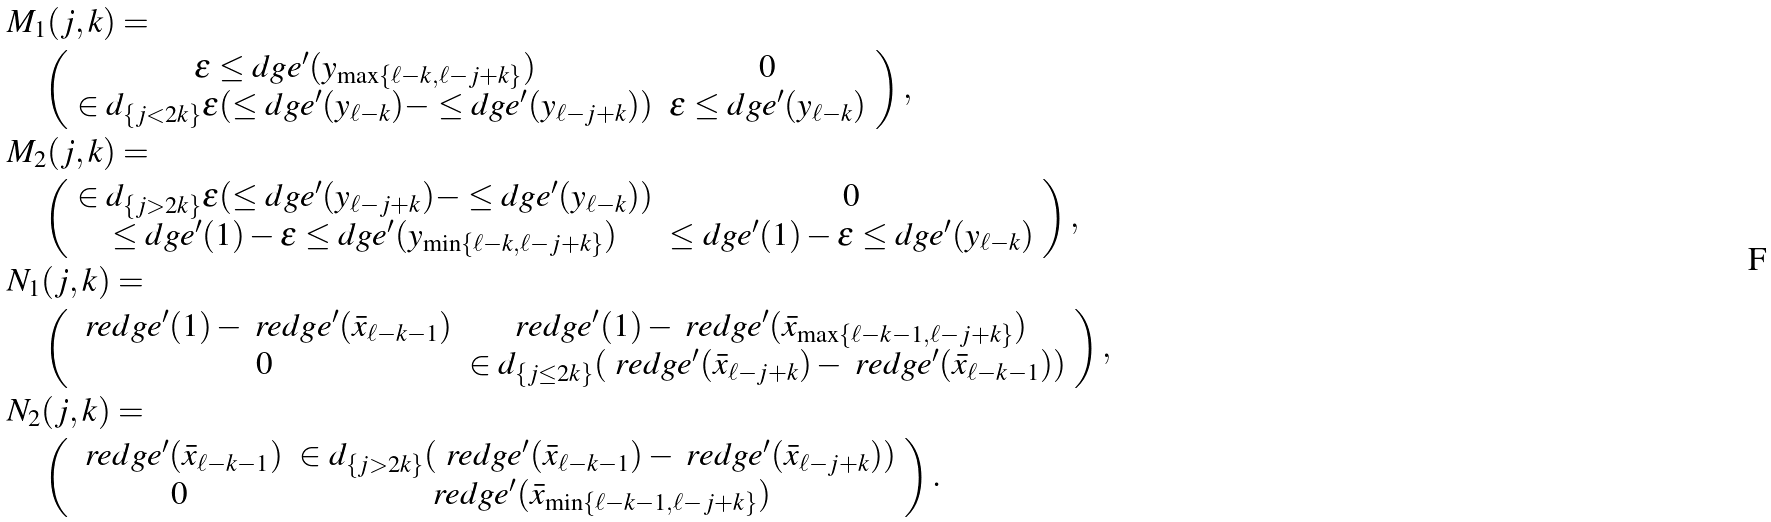Convert formula to latex. <formula><loc_0><loc_0><loc_500><loc_500>& M _ { 1 } ( j , k ) = \\ & \quad \left ( \begin{array} { c c } \epsilon \leq d g e ^ { \prime } ( y _ { \max \{ \ell - k , \ell - j + k \} } ) & 0 \\ \in d _ { \{ j < 2 k \} } \epsilon ( \leq d g e ^ { \prime } ( y _ { \ell - k } ) - \leq d g e ^ { \prime } ( y _ { \ell - j + k } ) ) & \epsilon \leq d g e ^ { \prime } ( y _ { \ell - k } ) \end{array} \right ) , \\ & M _ { 2 } ( j , k ) = \\ & \quad \left ( \begin{array} { c c } \in d _ { \{ j > 2 k \} } \epsilon ( \leq d g e ^ { \prime } ( y _ { \ell - j + k } ) - \leq d g e ^ { \prime } ( y _ { \ell - k } ) ) & 0 \\ \leq d g e ^ { \prime } ( 1 ) - \epsilon \leq d g e ^ { \prime } ( y _ { \min \{ \ell - k , \ell - j + k \} } ) & \leq d g e ^ { \prime } ( 1 ) - \epsilon \leq d g e ^ { \prime } ( y _ { \ell - k } ) \end{array} \right ) , \\ & N _ { 1 } ( j , k ) = \\ & \quad \left ( \begin{array} { c c } \ r e d g e ^ { \prime } ( 1 ) - \ r e d g e ^ { \prime } ( \bar { x } _ { \ell - k - 1 } ) & \ r e d g e ^ { \prime } ( 1 ) - \ r e d g e ^ { \prime } ( \bar { x } _ { \max \{ \ell - k - 1 , \ell - j + k \} } ) \\ 0 & \in d _ { \{ j \leq 2 k \} } ( \ r e d g e ^ { \prime } ( \bar { x } _ { \ell - j + k } ) - \ r e d g e ^ { \prime } ( \bar { x } _ { \ell - k - 1 } ) ) \end{array} \right ) , \\ & N _ { 2 } ( j , k ) = \\ & \quad \left ( \begin{array} { c c } \ r e d g e ^ { \prime } ( \bar { x } _ { \ell - k - 1 } ) & \in d _ { \{ j > 2 k \} } ( \ r e d g e ^ { \prime } ( \bar { x } _ { \ell - k - 1 } ) - \ r e d g e ^ { \prime } ( \bar { x } _ { \ell - j + k } ) ) \\ 0 & \ r e d g e ^ { \prime } ( \bar { x } _ { \min \{ \ell - k - 1 , \ell - j + k \} } ) \end{array} \right ) .</formula> 